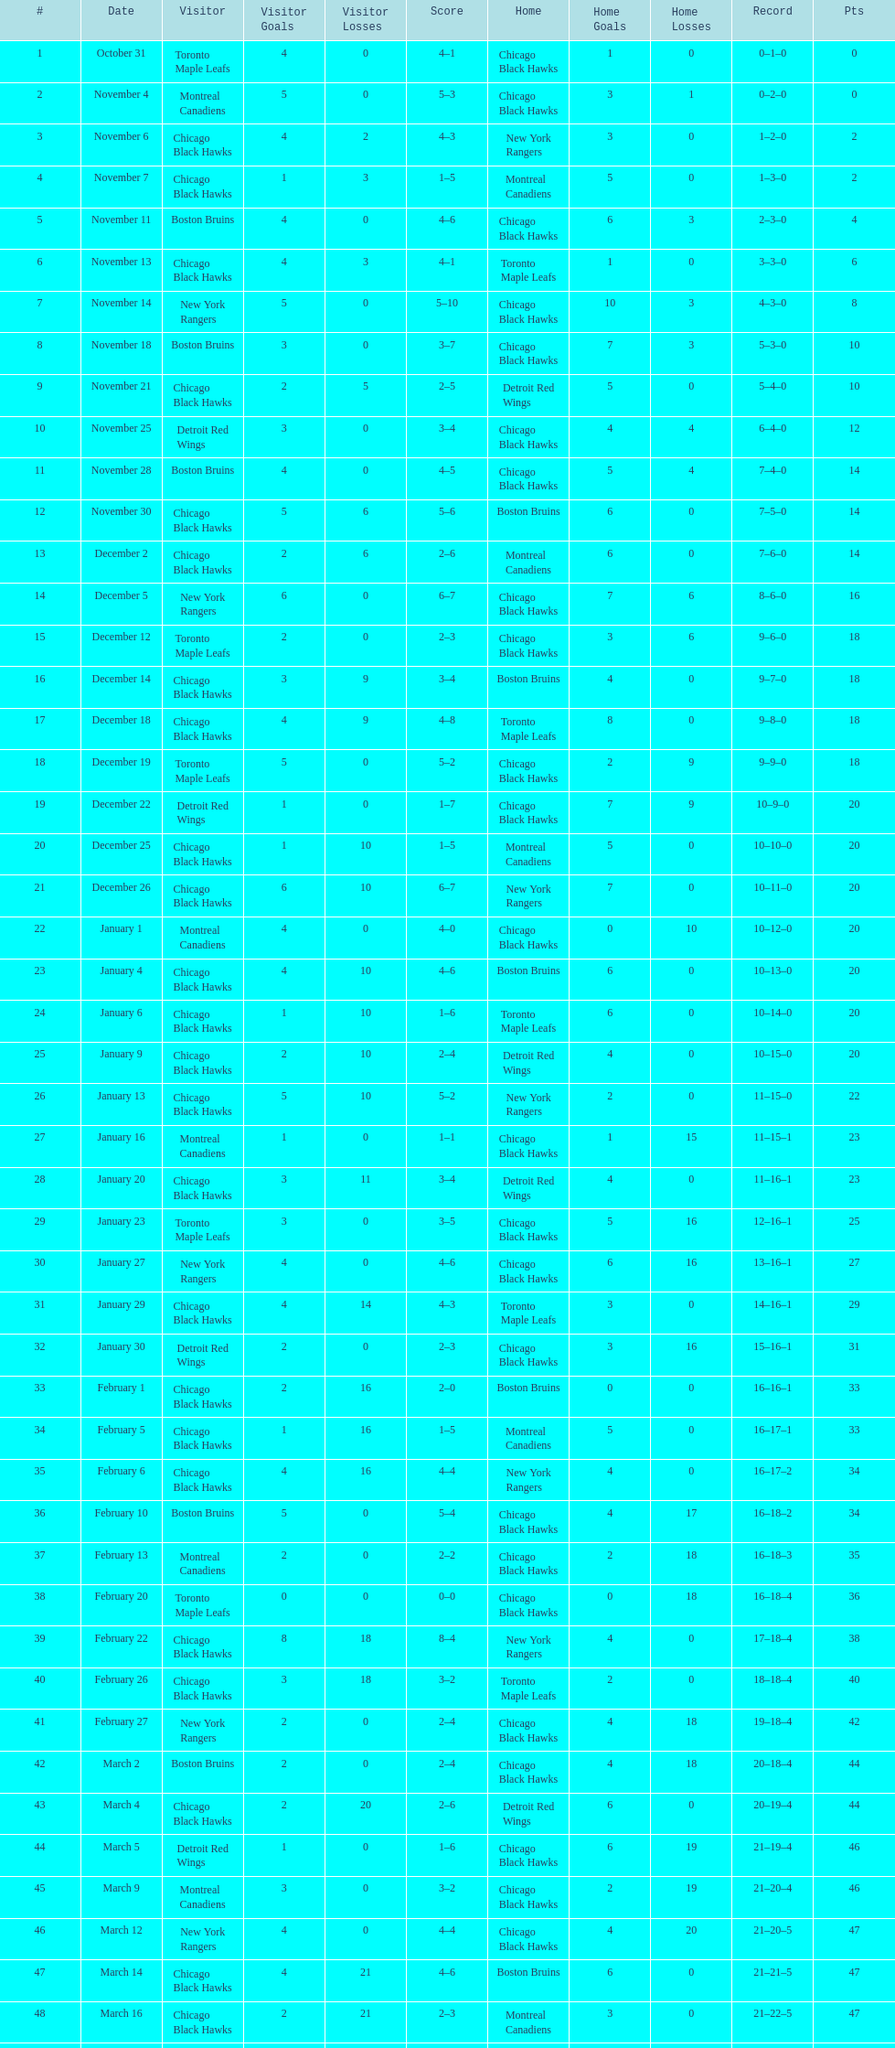Over what period does one season last, beginning with the first game and concluding with the last? 5 months. 